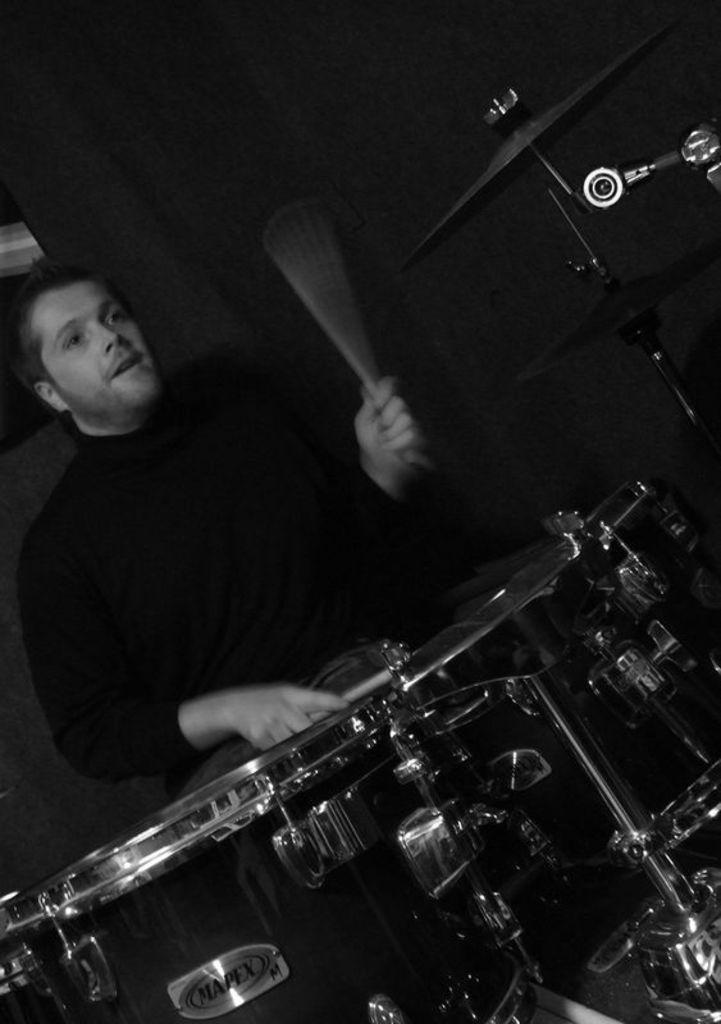Could you give a brief overview of what you see in this image? In this image I can see a drum set in the front and behind it I can see a man, I can see he is holding few drumsticks and on the bottom side of this image I can see something is written. I can also see this image is black and white in colour. 